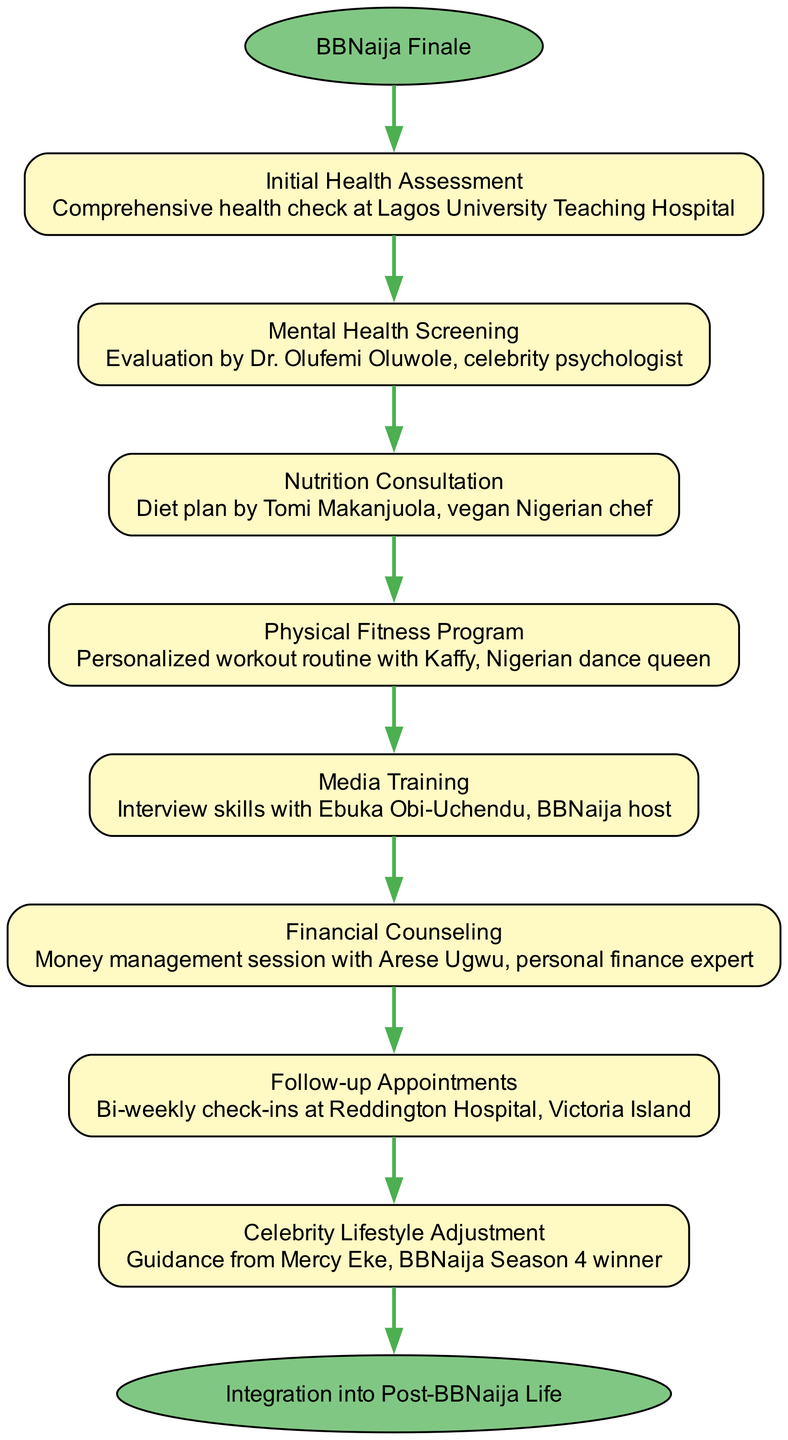what's the starting point of the clinical pathway? The starting point is labeled "BBNaija Finale" in the diagram, indicating where the process begins.
Answer: BBNaija Finale how many elements are there in the pathway? Counting the nodes in the pathway, there are eight distinct elements listed between the start and end points.
Answer: 8 which element follows "Initial Health Assessment"? The arrow connecting "Initial Health Assessment" to the next node points to "Mental Health Screening," indicating this is the next step in the process.
Answer: Mental Health Screening what is the last step before integration into post-BBNaija life? The last element in the list, just before the endpoint, is "Celebrity Lifestyle Adjustment," which transitions into the final integration stage.
Answer: Celebrity Lifestyle Adjustment who conducts the mental health screening? Looking at the description associated with the "Mental Health Screening" node, it specifies that this evaluation is performed by Dr. Olufemi Oluwole.
Answer: Dr. Olufemi Oluwole how often are the follow-up appointments scheduled? The description for "Follow-up Appointments" states they occur bi-weekly, indicating the frequency of these check-ins.
Answer: Bi-weekly what type of program is associated with Kaffy in the pathway? The node that includes Kaffy's involvement describes it as a "Physical Fitness Program," highlighting her role and the focus of the program.
Answer: Physical Fitness Program which professional provides the nutrition consultation? The element "Nutrition Consultation" specifies that it is provided by Tomi Makanjuola, indicating her expertise in this area.
Answer: Tomi Makanjuola what is the endpoint of this clinical pathway? The endpoint node is labeled "Integration into Post-BBNaija Life," which signifies the conclusion of the follow-up process.
Answer: Integration into Post-BBNaija Life 